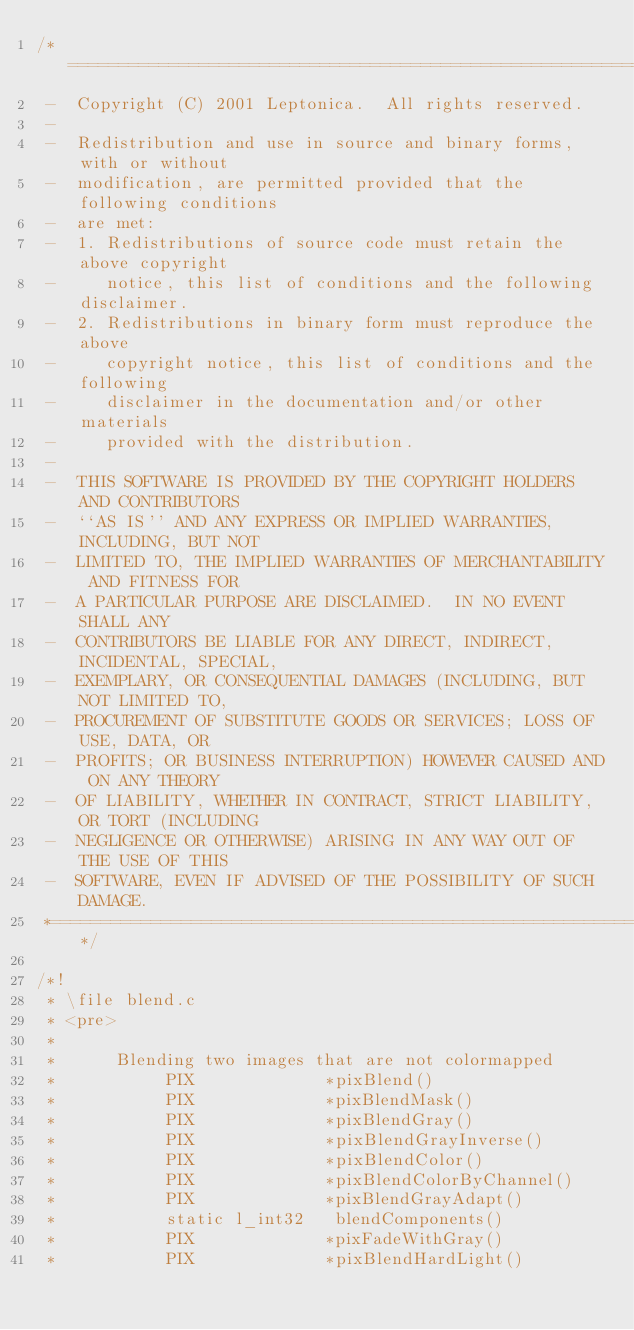<code> <loc_0><loc_0><loc_500><loc_500><_C_>/*====================================================================*
 -  Copyright (C) 2001 Leptonica.  All rights reserved.
 -
 -  Redistribution and use in source and binary forms, with or without
 -  modification, are permitted provided that the following conditions
 -  are met:
 -  1. Redistributions of source code must retain the above copyright
 -     notice, this list of conditions and the following disclaimer.
 -  2. Redistributions in binary form must reproduce the above
 -     copyright notice, this list of conditions and the following
 -     disclaimer in the documentation and/or other materials
 -     provided with the distribution.
 -
 -  THIS SOFTWARE IS PROVIDED BY THE COPYRIGHT HOLDERS AND CONTRIBUTORS
 -  ``AS IS'' AND ANY EXPRESS OR IMPLIED WARRANTIES, INCLUDING, BUT NOT
 -  LIMITED TO, THE IMPLIED WARRANTIES OF MERCHANTABILITY AND FITNESS FOR
 -  A PARTICULAR PURPOSE ARE DISCLAIMED.  IN NO EVENT SHALL ANY
 -  CONTRIBUTORS BE LIABLE FOR ANY DIRECT, INDIRECT, INCIDENTAL, SPECIAL,
 -  EXEMPLARY, OR CONSEQUENTIAL DAMAGES (INCLUDING, BUT NOT LIMITED TO,
 -  PROCUREMENT OF SUBSTITUTE GOODS OR SERVICES; LOSS OF USE, DATA, OR
 -  PROFITS; OR BUSINESS INTERRUPTION) HOWEVER CAUSED AND ON ANY THEORY
 -  OF LIABILITY, WHETHER IN CONTRACT, STRICT LIABILITY, OR TORT (INCLUDING
 -  NEGLIGENCE OR OTHERWISE) ARISING IN ANY WAY OUT OF THE USE OF THIS
 -  SOFTWARE, EVEN IF ADVISED OF THE POSSIBILITY OF SUCH DAMAGE.
 *====================================================================*/

/*!
 * \file blend.c
 * <pre>
 *
 *      Blending two images that are not colormapped
 *           PIX             *pixBlend()
 *           PIX             *pixBlendMask()
 *           PIX             *pixBlendGray()
 *           PIX             *pixBlendGrayInverse()
 *           PIX             *pixBlendColor()
 *           PIX             *pixBlendColorByChannel()
 *           PIX             *pixBlendGrayAdapt()
 *           static l_int32   blendComponents()
 *           PIX             *pixFadeWithGray()
 *           PIX             *pixBlendHardLight()</code> 